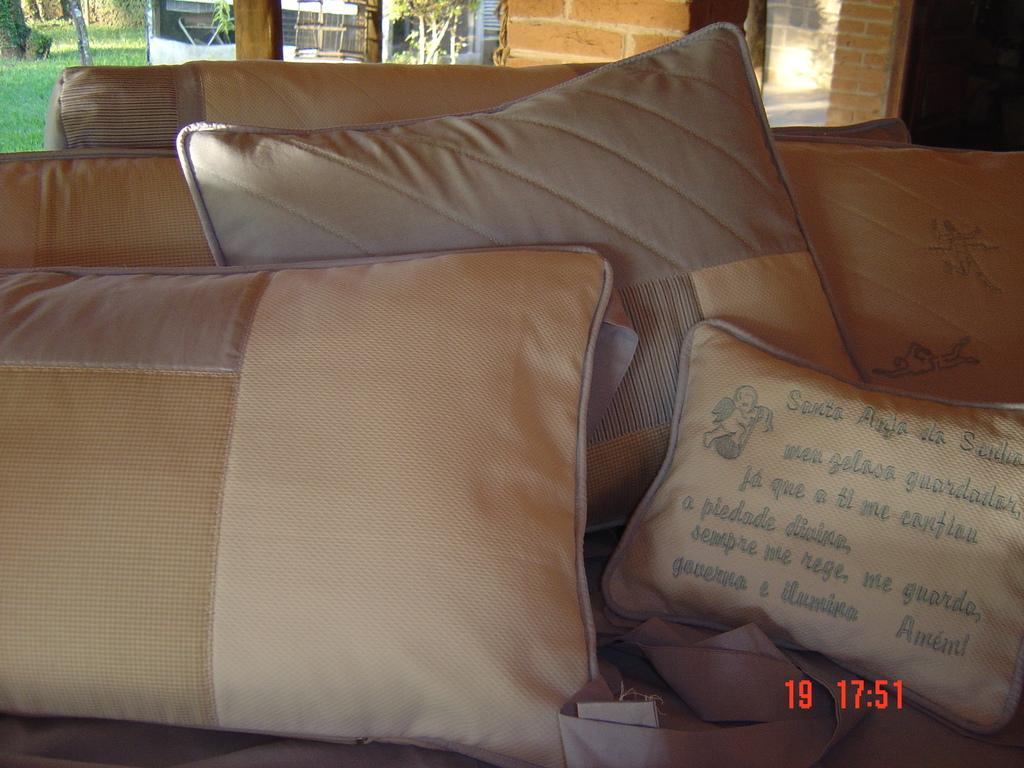What is on the bed in the image? There are pillows on the bed in the image. What can be seen on the right side of the image? There is a wall at the right side of the image. What type of landscape is visible on the left side of the image? There is a grassland at the left side of the image. How many cows are grazing in the grassland on the left side of the image? There are no cows visible in the image; it only shows a grassland. 